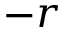<formula> <loc_0><loc_0><loc_500><loc_500>- r</formula> 